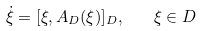Convert formula to latex. <formula><loc_0><loc_0><loc_500><loc_500>\dot { \xi } = [ \xi , A _ { D } ( \xi ) ] _ { D } , \quad \xi \in D</formula> 